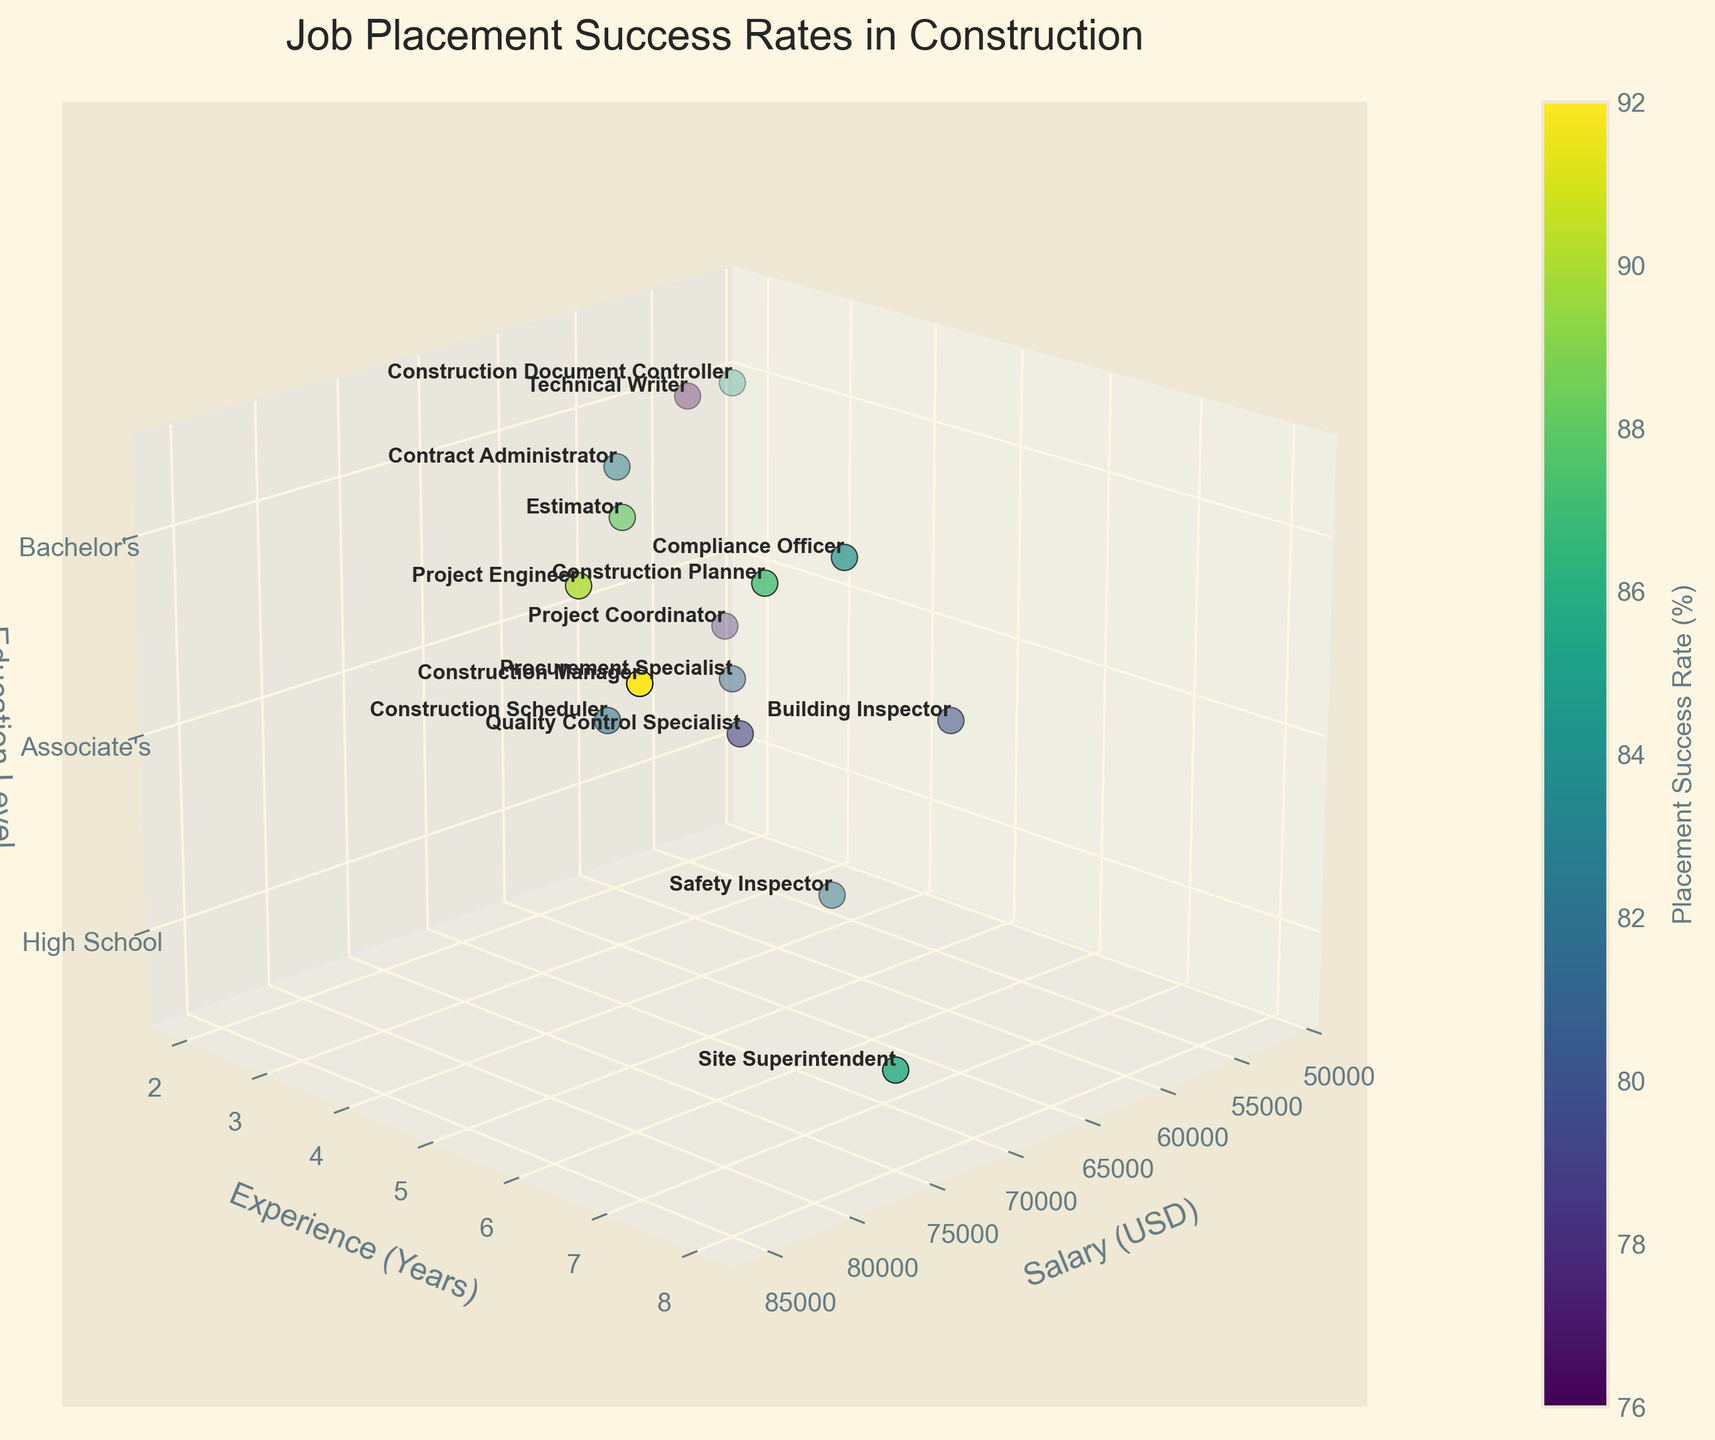what does the title of the plot indicate? The title "Job Placement Success Rates in Construction" suggests that the plot is about the success rates for job placements in the construction industry. It indicates that the figure displays various factors, like salary, experience, and education level, influencing these success rates.
Answer: Job Placement Success Rates in Construction What are the axis labels and what do they represent? The x-axis label is "Salary (USD)," representing the annual salary in US dollars. The y-axis label is "Experience (Years)," representing the number of years of experience. The z-axis label is "Education Level," representing the highest education level attained, with specific markers for "High School," "Associate's," and "Bachelor's."
Answer: Salary (USD), Experience (Years), Education Level How is the education level represented in the plot? The education level is represented on the z-axis with numerical values where "High School" is 1, "Associate's" is 2, and "Bachelor's" is 3.
Answer: Numerical values on the z-axis Which job title has the highest placement success rate, and what are its corresponding salary, experience, and education level? The job title "Construction Manager" has the highest placement success rate of 92%. It corresponds to a salary of 85,000 USD, 7 years of experience, and a Bachelor's degree.
Answer: Construction Manager; 85,000 USD; 7 years; Bachelor's How does the color on the plot relate to the data? The color represents the placement success rates. Darker and more intense colors indicate higher placement success rates, while lighter colors indicate lower success rates.
Answer: Placement success rates Which job has the highest salary, and what is its placement success rate? The job title "Construction Manager" has the highest salary of 85,000 USD and a placement success rate of 92%.
Answer: Construction Manager; 92% Compare the placement success rate and education level between "Quality Control Specialist" and "Procurement Specialist." "Quality Control Specialist" has a placement success rate of 79% and an education level equivalent to "Associate's." "Procurement Specialist" has a placement success rate of 81% with the same education level of "Associate's."
Answer: 79% and Associate's vs. 81% and Associate's Among jobs requiring a Bachelor's degree, which one has the lowest placement success rate, and what is it? The job "Technical Writer" has the lowest placement success rate among jobs requiring a Bachelor's degree, with a rate of 76%.
Answer: Technical Writer; 76% Which position has the most years of experience required for the highest placement success rate? The "Construction Manager" position requires 7 years of experience and has the highest placement success rate of 92%.
Answer: Construction Manager; 7 years; 92% What is the average salary for the job titles with a placement success rate higher than 85%? First, identify the job titles with placement success rates higher than 85%: "Construction Document Controller," "Estimator," "Construction Manager," "Project Engineer," and "Construction Planner." Their salaries are 52,000, 70,000, 85,000, 78,000, and 72,000 USD, respectively. The sum is 357,000 USD, and the average is 357,000/5 = 71,400 USD.
Answer: 71,400 USD 